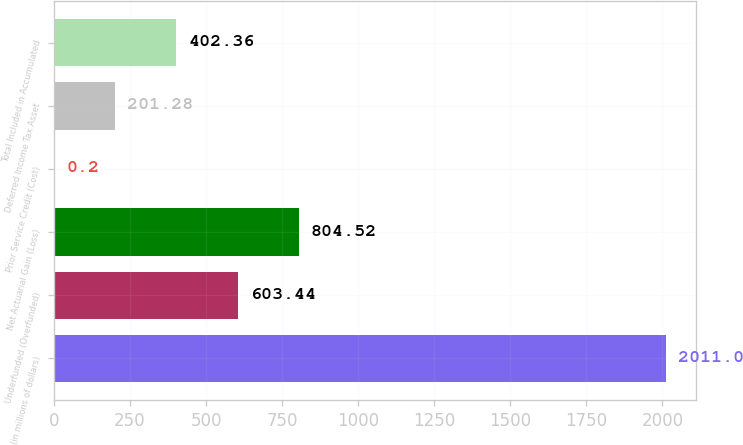Convert chart to OTSL. <chart><loc_0><loc_0><loc_500><loc_500><bar_chart><fcel>(in millions of dollars)<fcel>Underfunded (Overfunded)<fcel>Net Actuarial Gain (Loss)<fcel>Prior Service Credit (Cost)<fcel>Deferred Income Tax Asset<fcel>Total Included in Accumulated<nl><fcel>2011<fcel>603.44<fcel>804.52<fcel>0.2<fcel>201.28<fcel>402.36<nl></chart> 